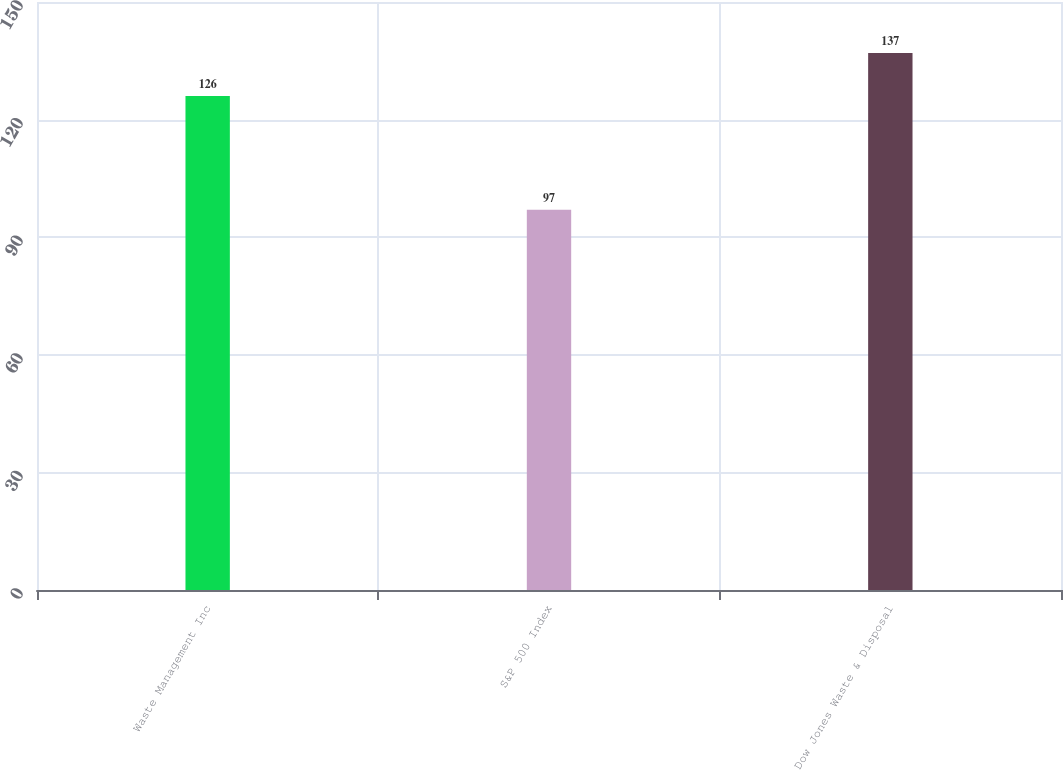Convert chart to OTSL. <chart><loc_0><loc_0><loc_500><loc_500><bar_chart><fcel>Waste Management Inc<fcel>S&P 500 Index<fcel>Dow Jones Waste & Disposal<nl><fcel>126<fcel>97<fcel>137<nl></chart> 